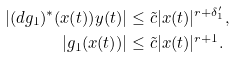Convert formula to latex. <formula><loc_0><loc_0><loc_500><loc_500>| ( d g _ { 1 } ) ^ { * } ( x ( t ) ) y ( t ) | & \leq \tilde { c } | x ( t ) | ^ { r + \delta ^ { \prime } _ { 1 } } , \\ | g _ { 1 } ( x ( t ) ) | & \leq \tilde { c } | x ( t ) | ^ { r + 1 } .</formula> 